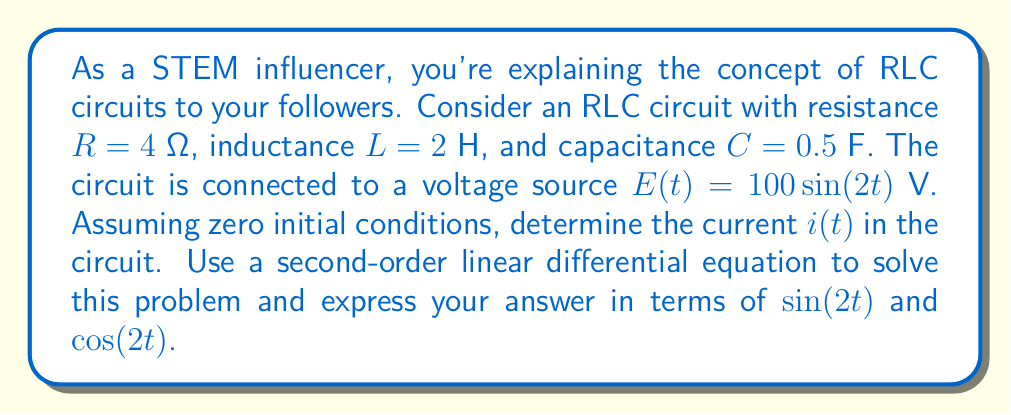Teach me how to tackle this problem. Let's approach this step-by-step:

1) The second-order linear differential equation for an RLC circuit is:

   $$L\frac{d^2i}{dt^2} + R\frac{di}{dt} + \frac{1}{C}i = E(t)$$

2) Substituting the given values:

   $$2\frac{d^2i}{dt^2} + 4\frac{di}{dt} + 2i = 100\sin(2t)$$

3) The general solution to this equation is the sum of the complementary function (solution to the homogeneous equation) and the particular integral (solution to the non-homogeneous equation).

4) For the particular integral, we assume a solution of the form:

   $$i_p(t) = A\sin(2t) + B\cos(2t)$$

5) Substituting this into the original equation:

   $$2(-4A\sin(2t)-4B\cos(2t)) + 4(2A\cos(2t)-2B\sin(2t)) + 2(A\sin(2t)+B\cos(2t)) = 100\sin(2t)$$

6) Simplifying and equating coefficients:

   $$(-8A+8A-2B+2A)\sin(2t) + (-8B+8B+2A+2B)\cos(2t) = 100\sin(2t)$$
   
   $$2A-2B = 100$$
   $$2A+2B = 0$$

7) Solving these simultaneous equations:

   $$A = 25, B = -25$$

8) Therefore, the particular integral is:

   $$i_p(t) = 25\sin(2t) - 25\cos(2t)$$

9) The complementary function would be of the form $Ae^{-t} + Be^{-t}$, but since we have zero initial conditions, these terms will be zero.

10) Thus, the complete solution is just the particular integral:

    $$i(t) = 25\sin(2t) - 25\cos(2t)$$
Answer: $$i(t) = 25\sin(2t) - 25\cos(2t)$$ amperes 